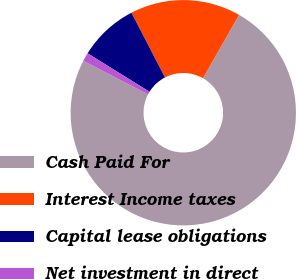Convert chart. <chart><loc_0><loc_0><loc_500><loc_500><pie_chart><fcel>Cash Paid For<fcel>Interest Income taxes<fcel>Capital lease obligations<fcel>Net investment in direct<nl><fcel>74.38%<fcel>15.86%<fcel>8.54%<fcel>1.22%<nl></chart> 